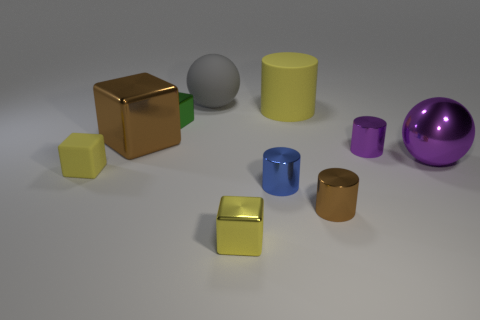Can you describe the texture of the objects? Certainly! The objects display a variety of textures: the cubes and the sphere have glossy finishes, while the cylinders have a matt-like texture that diffuses light more evenly. 